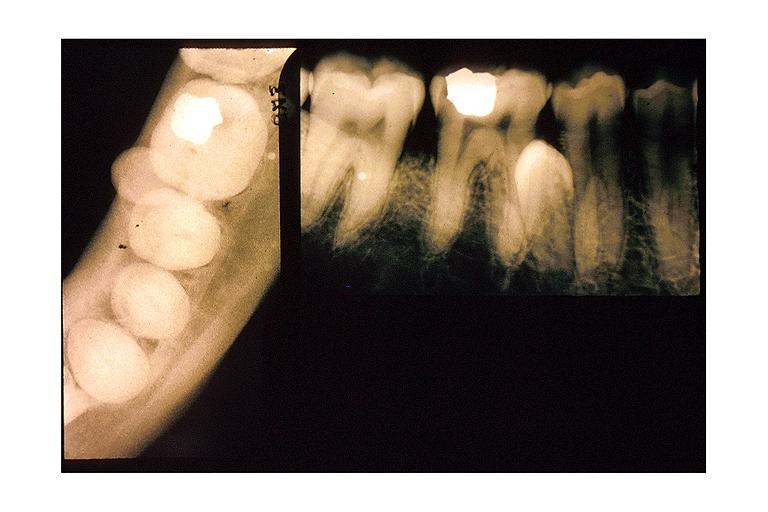s oral present?
Answer the question using a single word or phrase. Yes 